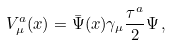Convert formula to latex. <formula><loc_0><loc_0><loc_500><loc_500>V _ { \mu } ^ { a } ( x ) = \bar { \Psi } ( x ) \gamma _ { \mu } { \frac { \tau ^ { a } } { 2 } } \Psi \, ,</formula> 